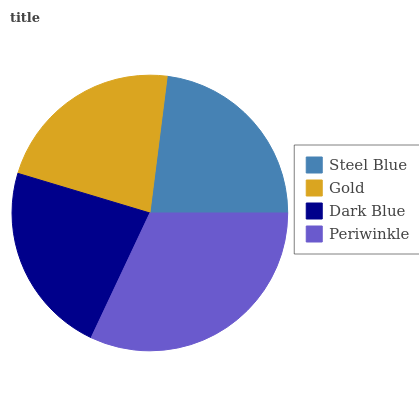Is Gold the minimum?
Answer yes or no. Yes. Is Periwinkle the maximum?
Answer yes or no. Yes. Is Dark Blue the minimum?
Answer yes or no. No. Is Dark Blue the maximum?
Answer yes or no. No. Is Dark Blue greater than Gold?
Answer yes or no. Yes. Is Gold less than Dark Blue?
Answer yes or no. Yes. Is Gold greater than Dark Blue?
Answer yes or no. No. Is Dark Blue less than Gold?
Answer yes or no. No. Is Steel Blue the high median?
Answer yes or no. Yes. Is Dark Blue the low median?
Answer yes or no. Yes. Is Gold the high median?
Answer yes or no. No. Is Periwinkle the low median?
Answer yes or no. No. 